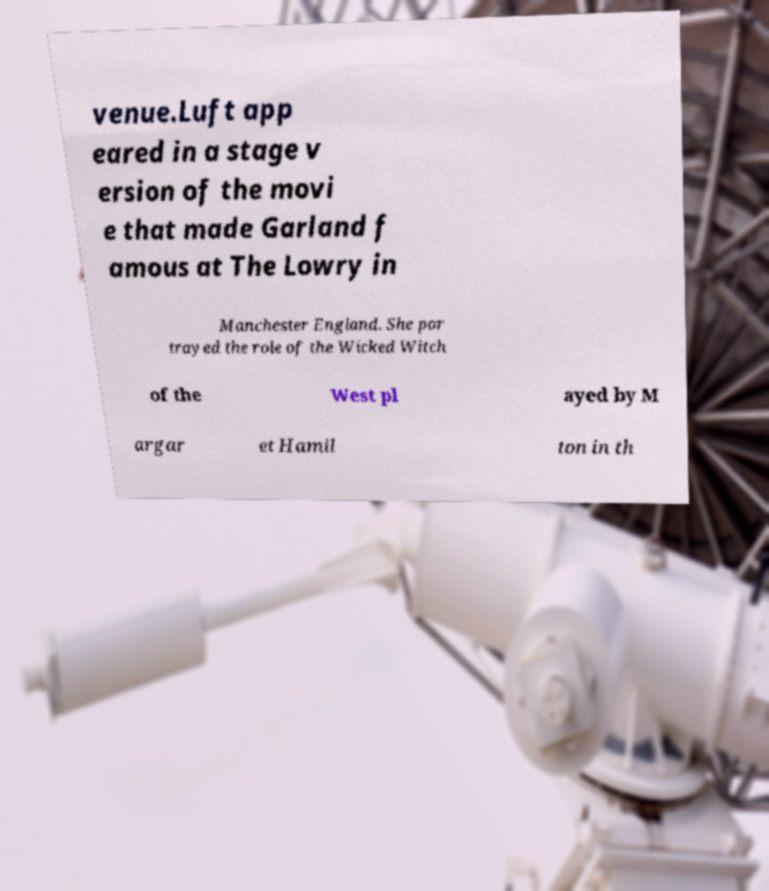For documentation purposes, I need the text within this image transcribed. Could you provide that? venue.Luft app eared in a stage v ersion of the movi e that made Garland f amous at The Lowry in Manchester England. She por trayed the role of the Wicked Witch of the West pl ayed by M argar et Hamil ton in th 